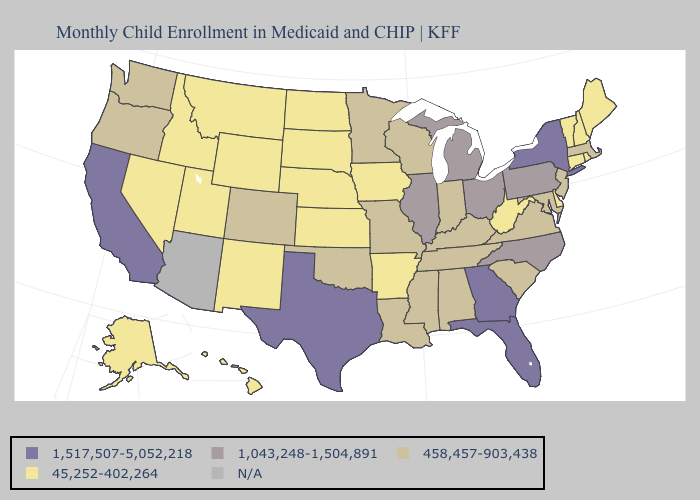Name the states that have a value in the range 45,252-402,264?
Keep it brief. Alaska, Arkansas, Connecticut, Delaware, Hawaii, Idaho, Iowa, Kansas, Maine, Montana, Nebraska, Nevada, New Hampshire, New Mexico, North Dakota, Rhode Island, South Dakota, Utah, Vermont, West Virginia, Wyoming. Does Oregon have the lowest value in the West?
Give a very brief answer. No. Name the states that have a value in the range N/A?
Be succinct. Arizona. Name the states that have a value in the range N/A?
Concise answer only. Arizona. Which states have the highest value in the USA?
Concise answer only. California, Florida, Georgia, New York, Texas. Name the states that have a value in the range 1,043,248-1,504,891?
Write a very short answer. Illinois, Michigan, North Carolina, Ohio, Pennsylvania. Does Oregon have the lowest value in the USA?
Keep it brief. No. Does California have the highest value in the West?
Write a very short answer. Yes. Does the first symbol in the legend represent the smallest category?
Answer briefly. No. Name the states that have a value in the range 1,043,248-1,504,891?
Short answer required. Illinois, Michigan, North Carolina, Ohio, Pennsylvania. Which states have the lowest value in the West?
Write a very short answer. Alaska, Hawaii, Idaho, Montana, Nevada, New Mexico, Utah, Wyoming. What is the value of Colorado?
Concise answer only. 458,457-903,438. What is the value of Connecticut?
Concise answer only. 45,252-402,264. 